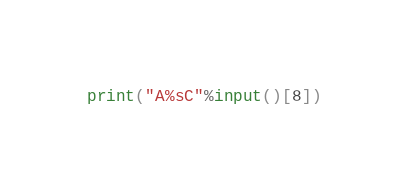Convert code to text. <code><loc_0><loc_0><loc_500><loc_500><_Python_>print("A%sC"%input()[8])</code> 